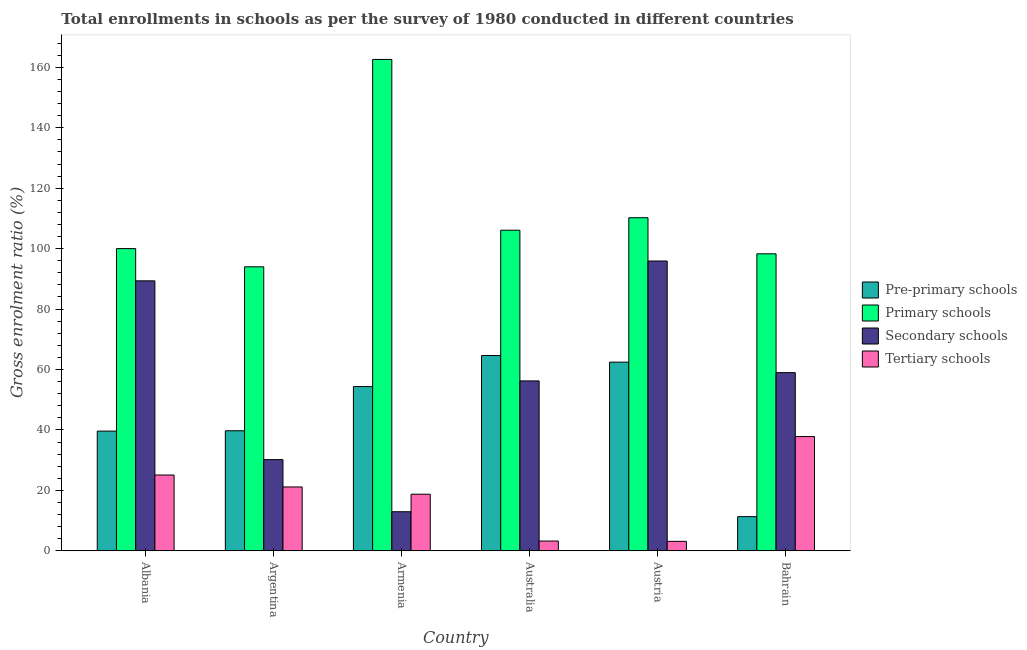How many different coloured bars are there?
Your response must be concise. 4. How many bars are there on the 2nd tick from the left?
Keep it short and to the point. 4. What is the label of the 2nd group of bars from the left?
Your answer should be compact. Argentina. What is the gross enrolment ratio in pre-primary schools in Armenia?
Make the answer very short. 54.34. Across all countries, what is the maximum gross enrolment ratio in primary schools?
Give a very brief answer. 162.62. Across all countries, what is the minimum gross enrolment ratio in secondary schools?
Make the answer very short. 12.93. In which country was the gross enrolment ratio in pre-primary schools maximum?
Ensure brevity in your answer.  Australia. What is the total gross enrolment ratio in pre-primary schools in the graph?
Give a very brief answer. 272.01. What is the difference between the gross enrolment ratio in tertiary schools in Albania and that in Argentina?
Ensure brevity in your answer.  3.95. What is the difference between the gross enrolment ratio in pre-primary schools in Australia and the gross enrolment ratio in tertiary schools in Argentina?
Make the answer very short. 43.5. What is the average gross enrolment ratio in tertiary schools per country?
Offer a very short reply. 18.18. What is the difference between the gross enrolment ratio in pre-primary schools and gross enrolment ratio in tertiary schools in Bahrain?
Ensure brevity in your answer.  -26.51. What is the ratio of the gross enrolment ratio in tertiary schools in Argentina to that in Armenia?
Offer a terse response. 1.13. Is the gross enrolment ratio in secondary schools in Albania less than that in Armenia?
Your answer should be compact. No. Is the difference between the gross enrolment ratio in secondary schools in Albania and Austria greater than the difference between the gross enrolment ratio in tertiary schools in Albania and Austria?
Offer a very short reply. No. What is the difference between the highest and the second highest gross enrolment ratio in pre-primary schools?
Ensure brevity in your answer.  2.19. What is the difference between the highest and the lowest gross enrolment ratio in secondary schools?
Provide a short and direct response. 82.98. In how many countries, is the gross enrolment ratio in primary schools greater than the average gross enrolment ratio in primary schools taken over all countries?
Your answer should be very brief. 1. Is it the case that in every country, the sum of the gross enrolment ratio in pre-primary schools and gross enrolment ratio in secondary schools is greater than the sum of gross enrolment ratio in primary schools and gross enrolment ratio in tertiary schools?
Make the answer very short. Yes. What does the 3rd bar from the left in Armenia represents?
Your answer should be compact. Secondary schools. What does the 4th bar from the right in Argentina represents?
Make the answer very short. Pre-primary schools. Is it the case that in every country, the sum of the gross enrolment ratio in pre-primary schools and gross enrolment ratio in primary schools is greater than the gross enrolment ratio in secondary schools?
Provide a succinct answer. Yes. How many bars are there?
Provide a succinct answer. 24. What is the difference between two consecutive major ticks on the Y-axis?
Make the answer very short. 20. Does the graph contain grids?
Keep it short and to the point. No. How many legend labels are there?
Offer a terse response. 4. What is the title of the graph?
Provide a succinct answer. Total enrollments in schools as per the survey of 1980 conducted in different countries. What is the Gross enrolment ratio (%) of Pre-primary schools in Albania?
Offer a very short reply. 39.61. What is the Gross enrolment ratio (%) in Primary schools in Albania?
Give a very brief answer. 100.01. What is the Gross enrolment ratio (%) in Secondary schools in Albania?
Your answer should be compact. 89.34. What is the Gross enrolment ratio (%) in Tertiary schools in Albania?
Your response must be concise. 25.07. What is the Gross enrolment ratio (%) in Pre-primary schools in Argentina?
Offer a very short reply. 39.72. What is the Gross enrolment ratio (%) in Primary schools in Argentina?
Your response must be concise. 93.98. What is the Gross enrolment ratio (%) in Secondary schools in Argentina?
Your response must be concise. 30.17. What is the Gross enrolment ratio (%) in Tertiary schools in Argentina?
Your answer should be very brief. 21.12. What is the Gross enrolment ratio (%) of Pre-primary schools in Armenia?
Provide a short and direct response. 54.34. What is the Gross enrolment ratio (%) in Primary schools in Armenia?
Provide a short and direct response. 162.62. What is the Gross enrolment ratio (%) of Secondary schools in Armenia?
Offer a very short reply. 12.93. What is the Gross enrolment ratio (%) in Tertiary schools in Armenia?
Your answer should be very brief. 18.72. What is the Gross enrolment ratio (%) of Pre-primary schools in Australia?
Provide a succinct answer. 64.62. What is the Gross enrolment ratio (%) in Primary schools in Australia?
Provide a succinct answer. 106.1. What is the Gross enrolment ratio (%) in Secondary schools in Australia?
Ensure brevity in your answer.  56.22. What is the Gross enrolment ratio (%) of Tertiary schools in Australia?
Offer a terse response. 3.22. What is the Gross enrolment ratio (%) in Pre-primary schools in Austria?
Your answer should be compact. 62.43. What is the Gross enrolment ratio (%) in Primary schools in Austria?
Offer a terse response. 110.23. What is the Gross enrolment ratio (%) in Secondary schools in Austria?
Keep it short and to the point. 95.9. What is the Gross enrolment ratio (%) of Tertiary schools in Austria?
Offer a very short reply. 3.12. What is the Gross enrolment ratio (%) in Pre-primary schools in Bahrain?
Your answer should be compact. 11.29. What is the Gross enrolment ratio (%) of Primary schools in Bahrain?
Give a very brief answer. 98.29. What is the Gross enrolment ratio (%) of Secondary schools in Bahrain?
Keep it short and to the point. 58.96. What is the Gross enrolment ratio (%) in Tertiary schools in Bahrain?
Provide a succinct answer. 37.8. Across all countries, what is the maximum Gross enrolment ratio (%) of Pre-primary schools?
Make the answer very short. 64.62. Across all countries, what is the maximum Gross enrolment ratio (%) in Primary schools?
Offer a very short reply. 162.62. Across all countries, what is the maximum Gross enrolment ratio (%) of Secondary schools?
Your answer should be compact. 95.9. Across all countries, what is the maximum Gross enrolment ratio (%) of Tertiary schools?
Your response must be concise. 37.8. Across all countries, what is the minimum Gross enrolment ratio (%) in Pre-primary schools?
Offer a terse response. 11.29. Across all countries, what is the minimum Gross enrolment ratio (%) in Primary schools?
Provide a short and direct response. 93.98. Across all countries, what is the minimum Gross enrolment ratio (%) in Secondary schools?
Your response must be concise. 12.93. Across all countries, what is the minimum Gross enrolment ratio (%) in Tertiary schools?
Offer a very short reply. 3.12. What is the total Gross enrolment ratio (%) of Pre-primary schools in the graph?
Ensure brevity in your answer.  272.01. What is the total Gross enrolment ratio (%) in Primary schools in the graph?
Ensure brevity in your answer.  671.23. What is the total Gross enrolment ratio (%) in Secondary schools in the graph?
Ensure brevity in your answer.  343.53. What is the total Gross enrolment ratio (%) of Tertiary schools in the graph?
Ensure brevity in your answer.  109.06. What is the difference between the Gross enrolment ratio (%) in Pre-primary schools in Albania and that in Argentina?
Offer a very short reply. -0.11. What is the difference between the Gross enrolment ratio (%) of Primary schools in Albania and that in Argentina?
Your answer should be very brief. 6.03. What is the difference between the Gross enrolment ratio (%) in Secondary schools in Albania and that in Argentina?
Provide a short and direct response. 59.17. What is the difference between the Gross enrolment ratio (%) in Tertiary schools in Albania and that in Argentina?
Give a very brief answer. 3.95. What is the difference between the Gross enrolment ratio (%) in Pre-primary schools in Albania and that in Armenia?
Provide a short and direct response. -14.74. What is the difference between the Gross enrolment ratio (%) of Primary schools in Albania and that in Armenia?
Your answer should be compact. -62.61. What is the difference between the Gross enrolment ratio (%) of Secondary schools in Albania and that in Armenia?
Provide a succinct answer. 76.42. What is the difference between the Gross enrolment ratio (%) of Tertiary schools in Albania and that in Armenia?
Give a very brief answer. 6.35. What is the difference between the Gross enrolment ratio (%) in Pre-primary schools in Albania and that in Australia?
Keep it short and to the point. -25.01. What is the difference between the Gross enrolment ratio (%) of Primary schools in Albania and that in Australia?
Offer a terse response. -6.09. What is the difference between the Gross enrolment ratio (%) of Secondary schools in Albania and that in Australia?
Give a very brief answer. 33.12. What is the difference between the Gross enrolment ratio (%) in Tertiary schools in Albania and that in Australia?
Provide a succinct answer. 21.85. What is the difference between the Gross enrolment ratio (%) of Pre-primary schools in Albania and that in Austria?
Your answer should be very brief. -22.82. What is the difference between the Gross enrolment ratio (%) of Primary schools in Albania and that in Austria?
Your answer should be compact. -10.22. What is the difference between the Gross enrolment ratio (%) in Secondary schools in Albania and that in Austria?
Make the answer very short. -6.56. What is the difference between the Gross enrolment ratio (%) in Tertiary schools in Albania and that in Austria?
Ensure brevity in your answer.  21.95. What is the difference between the Gross enrolment ratio (%) of Pre-primary schools in Albania and that in Bahrain?
Your answer should be compact. 28.31. What is the difference between the Gross enrolment ratio (%) in Primary schools in Albania and that in Bahrain?
Provide a succinct answer. 1.72. What is the difference between the Gross enrolment ratio (%) in Secondary schools in Albania and that in Bahrain?
Your response must be concise. 30.38. What is the difference between the Gross enrolment ratio (%) of Tertiary schools in Albania and that in Bahrain?
Your response must be concise. -12.73. What is the difference between the Gross enrolment ratio (%) in Pre-primary schools in Argentina and that in Armenia?
Keep it short and to the point. -14.63. What is the difference between the Gross enrolment ratio (%) of Primary schools in Argentina and that in Armenia?
Provide a short and direct response. -68.63. What is the difference between the Gross enrolment ratio (%) in Secondary schools in Argentina and that in Armenia?
Your response must be concise. 17.25. What is the difference between the Gross enrolment ratio (%) of Tertiary schools in Argentina and that in Armenia?
Provide a short and direct response. 2.4. What is the difference between the Gross enrolment ratio (%) of Pre-primary schools in Argentina and that in Australia?
Keep it short and to the point. -24.9. What is the difference between the Gross enrolment ratio (%) in Primary schools in Argentina and that in Australia?
Offer a very short reply. -12.11. What is the difference between the Gross enrolment ratio (%) of Secondary schools in Argentina and that in Australia?
Offer a terse response. -26.05. What is the difference between the Gross enrolment ratio (%) in Tertiary schools in Argentina and that in Australia?
Your response must be concise. 17.9. What is the difference between the Gross enrolment ratio (%) in Pre-primary schools in Argentina and that in Austria?
Make the answer very short. -22.71. What is the difference between the Gross enrolment ratio (%) in Primary schools in Argentina and that in Austria?
Provide a short and direct response. -16.25. What is the difference between the Gross enrolment ratio (%) of Secondary schools in Argentina and that in Austria?
Your answer should be compact. -65.73. What is the difference between the Gross enrolment ratio (%) of Tertiary schools in Argentina and that in Austria?
Offer a terse response. 18. What is the difference between the Gross enrolment ratio (%) of Pre-primary schools in Argentina and that in Bahrain?
Provide a short and direct response. 28.42. What is the difference between the Gross enrolment ratio (%) in Primary schools in Argentina and that in Bahrain?
Make the answer very short. -4.3. What is the difference between the Gross enrolment ratio (%) in Secondary schools in Argentina and that in Bahrain?
Keep it short and to the point. -28.79. What is the difference between the Gross enrolment ratio (%) of Tertiary schools in Argentina and that in Bahrain?
Your answer should be compact. -16.68. What is the difference between the Gross enrolment ratio (%) in Pre-primary schools in Armenia and that in Australia?
Offer a terse response. -10.27. What is the difference between the Gross enrolment ratio (%) in Primary schools in Armenia and that in Australia?
Keep it short and to the point. 56.52. What is the difference between the Gross enrolment ratio (%) of Secondary schools in Armenia and that in Australia?
Make the answer very short. -43.29. What is the difference between the Gross enrolment ratio (%) of Tertiary schools in Armenia and that in Australia?
Your answer should be very brief. 15.5. What is the difference between the Gross enrolment ratio (%) of Pre-primary schools in Armenia and that in Austria?
Your answer should be compact. -8.09. What is the difference between the Gross enrolment ratio (%) of Primary schools in Armenia and that in Austria?
Provide a succinct answer. 52.39. What is the difference between the Gross enrolment ratio (%) in Secondary schools in Armenia and that in Austria?
Offer a terse response. -82.98. What is the difference between the Gross enrolment ratio (%) of Tertiary schools in Armenia and that in Austria?
Ensure brevity in your answer.  15.6. What is the difference between the Gross enrolment ratio (%) in Pre-primary schools in Armenia and that in Bahrain?
Offer a terse response. 43.05. What is the difference between the Gross enrolment ratio (%) in Primary schools in Armenia and that in Bahrain?
Ensure brevity in your answer.  64.33. What is the difference between the Gross enrolment ratio (%) of Secondary schools in Armenia and that in Bahrain?
Give a very brief answer. -46.04. What is the difference between the Gross enrolment ratio (%) in Tertiary schools in Armenia and that in Bahrain?
Provide a succinct answer. -19.09. What is the difference between the Gross enrolment ratio (%) of Pre-primary schools in Australia and that in Austria?
Your response must be concise. 2.19. What is the difference between the Gross enrolment ratio (%) in Primary schools in Australia and that in Austria?
Ensure brevity in your answer.  -4.13. What is the difference between the Gross enrolment ratio (%) in Secondary schools in Australia and that in Austria?
Provide a short and direct response. -39.68. What is the difference between the Gross enrolment ratio (%) in Tertiary schools in Australia and that in Austria?
Offer a very short reply. 0.1. What is the difference between the Gross enrolment ratio (%) in Pre-primary schools in Australia and that in Bahrain?
Your answer should be very brief. 53.32. What is the difference between the Gross enrolment ratio (%) of Primary schools in Australia and that in Bahrain?
Your answer should be compact. 7.81. What is the difference between the Gross enrolment ratio (%) of Secondary schools in Australia and that in Bahrain?
Provide a succinct answer. -2.74. What is the difference between the Gross enrolment ratio (%) in Tertiary schools in Australia and that in Bahrain?
Offer a terse response. -34.58. What is the difference between the Gross enrolment ratio (%) of Pre-primary schools in Austria and that in Bahrain?
Keep it short and to the point. 51.14. What is the difference between the Gross enrolment ratio (%) of Primary schools in Austria and that in Bahrain?
Make the answer very short. 11.94. What is the difference between the Gross enrolment ratio (%) in Secondary schools in Austria and that in Bahrain?
Your answer should be very brief. 36.94. What is the difference between the Gross enrolment ratio (%) of Tertiary schools in Austria and that in Bahrain?
Your answer should be compact. -34.68. What is the difference between the Gross enrolment ratio (%) in Pre-primary schools in Albania and the Gross enrolment ratio (%) in Primary schools in Argentina?
Keep it short and to the point. -54.38. What is the difference between the Gross enrolment ratio (%) in Pre-primary schools in Albania and the Gross enrolment ratio (%) in Secondary schools in Argentina?
Your answer should be compact. 9.43. What is the difference between the Gross enrolment ratio (%) in Pre-primary schools in Albania and the Gross enrolment ratio (%) in Tertiary schools in Argentina?
Provide a short and direct response. 18.48. What is the difference between the Gross enrolment ratio (%) of Primary schools in Albania and the Gross enrolment ratio (%) of Secondary schools in Argentina?
Offer a very short reply. 69.84. What is the difference between the Gross enrolment ratio (%) of Primary schools in Albania and the Gross enrolment ratio (%) of Tertiary schools in Argentina?
Offer a very short reply. 78.89. What is the difference between the Gross enrolment ratio (%) in Secondary schools in Albania and the Gross enrolment ratio (%) in Tertiary schools in Argentina?
Give a very brief answer. 68.22. What is the difference between the Gross enrolment ratio (%) of Pre-primary schools in Albania and the Gross enrolment ratio (%) of Primary schools in Armenia?
Your response must be concise. -123.01. What is the difference between the Gross enrolment ratio (%) of Pre-primary schools in Albania and the Gross enrolment ratio (%) of Secondary schools in Armenia?
Offer a terse response. 26.68. What is the difference between the Gross enrolment ratio (%) of Pre-primary schools in Albania and the Gross enrolment ratio (%) of Tertiary schools in Armenia?
Your response must be concise. 20.89. What is the difference between the Gross enrolment ratio (%) in Primary schools in Albania and the Gross enrolment ratio (%) in Secondary schools in Armenia?
Provide a succinct answer. 87.09. What is the difference between the Gross enrolment ratio (%) of Primary schools in Albania and the Gross enrolment ratio (%) of Tertiary schools in Armenia?
Offer a terse response. 81.29. What is the difference between the Gross enrolment ratio (%) in Secondary schools in Albania and the Gross enrolment ratio (%) in Tertiary schools in Armenia?
Make the answer very short. 70.62. What is the difference between the Gross enrolment ratio (%) of Pre-primary schools in Albania and the Gross enrolment ratio (%) of Primary schools in Australia?
Offer a very short reply. -66.49. What is the difference between the Gross enrolment ratio (%) in Pre-primary schools in Albania and the Gross enrolment ratio (%) in Secondary schools in Australia?
Make the answer very short. -16.61. What is the difference between the Gross enrolment ratio (%) in Pre-primary schools in Albania and the Gross enrolment ratio (%) in Tertiary schools in Australia?
Make the answer very short. 36.38. What is the difference between the Gross enrolment ratio (%) in Primary schools in Albania and the Gross enrolment ratio (%) in Secondary schools in Australia?
Make the answer very short. 43.79. What is the difference between the Gross enrolment ratio (%) in Primary schools in Albania and the Gross enrolment ratio (%) in Tertiary schools in Australia?
Provide a succinct answer. 96.79. What is the difference between the Gross enrolment ratio (%) in Secondary schools in Albania and the Gross enrolment ratio (%) in Tertiary schools in Australia?
Ensure brevity in your answer.  86.12. What is the difference between the Gross enrolment ratio (%) of Pre-primary schools in Albania and the Gross enrolment ratio (%) of Primary schools in Austria?
Keep it short and to the point. -70.62. What is the difference between the Gross enrolment ratio (%) in Pre-primary schools in Albania and the Gross enrolment ratio (%) in Secondary schools in Austria?
Offer a very short reply. -56.3. What is the difference between the Gross enrolment ratio (%) in Pre-primary schools in Albania and the Gross enrolment ratio (%) in Tertiary schools in Austria?
Give a very brief answer. 36.49. What is the difference between the Gross enrolment ratio (%) of Primary schools in Albania and the Gross enrolment ratio (%) of Secondary schools in Austria?
Keep it short and to the point. 4.11. What is the difference between the Gross enrolment ratio (%) in Primary schools in Albania and the Gross enrolment ratio (%) in Tertiary schools in Austria?
Your response must be concise. 96.89. What is the difference between the Gross enrolment ratio (%) of Secondary schools in Albania and the Gross enrolment ratio (%) of Tertiary schools in Austria?
Your answer should be compact. 86.22. What is the difference between the Gross enrolment ratio (%) of Pre-primary schools in Albania and the Gross enrolment ratio (%) of Primary schools in Bahrain?
Your answer should be very brief. -58.68. What is the difference between the Gross enrolment ratio (%) of Pre-primary schools in Albania and the Gross enrolment ratio (%) of Secondary schools in Bahrain?
Provide a short and direct response. -19.36. What is the difference between the Gross enrolment ratio (%) of Pre-primary schools in Albania and the Gross enrolment ratio (%) of Tertiary schools in Bahrain?
Provide a short and direct response. 1.8. What is the difference between the Gross enrolment ratio (%) in Primary schools in Albania and the Gross enrolment ratio (%) in Secondary schools in Bahrain?
Give a very brief answer. 41.05. What is the difference between the Gross enrolment ratio (%) in Primary schools in Albania and the Gross enrolment ratio (%) in Tertiary schools in Bahrain?
Keep it short and to the point. 62.21. What is the difference between the Gross enrolment ratio (%) in Secondary schools in Albania and the Gross enrolment ratio (%) in Tertiary schools in Bahrain?
Offer a terse response. 51.54. What is the difference between the Gross enrolment ratio (%) in Pre-primary schools in Argentina and the Gross enrolment ratio (%) in Primary schools in Armenia?
Your answer should be compact. -122.9. What is the difference between the Gross enrolment ratio (%) of Pre-primary schools in Argentina and the Gross enrolment ratio (%) of Secondary schools in Armenia?
Your answer should be compact. 26.79. What is the difference between the Gross enrolment ratio (%) in Pre-primary schools in Argentina and the Gross enrolment ratio (%) in Tertiary schools in Armenia?
Your answer should be very brief. 21. What is the difference between the Gross enrolment ratio (%) of Primary schools in Argentina and the Gross enrolment ratio (%) of Secondary schools in Armenia?
Make the answer very short. 81.06. What is the difference between the Gross enrolment ratio (%) of Primary schools in Argentina and the Gross enrolment ratio (%) of Tertiary schools in Armenia?
Offer a terse response. 75.27. What is the difference between the Gross enrolment ratio (%) in Secondary schools in Argentina and the Gross enrolment ratio (%) in Tertiary schools in Armenia?
Your answer should be compact. 11.45. What is the difference between the Gross enrolment ratio (%) in Pre-primary schools in Argentina and the Gross enrolment ratio (%) in Primary schools in Australia?
Make the answer very short. -66.38. What is the difference between the Gross enrolment ratio (%) in Pre-primary schools in Argentina and the Gross enrolment ratio (%) in Secondary schools in Australia?
Offer a very short reply. -16.5. What is the difference between the Gross enrolment ratio (%) in Pre-primary schools in Argentina and the Gross enrolment ratio (%) in Tertiary schools in Australia?
Keep it short and to the point. 36.49. What is the difference between the Gross enrolment ratio (%) in Primary schools in Argentina and the Gross enrolment ratio (%) in Secondary schools in Australia?
Offer a very short reply. 37.76. What is the difference between the Gross enrolment ratio (%) in Primary schools in Argentina and the Gross enrolment ratio (%) in Tertiary schools in Australia?
Your answer should be very brief. 90.76. What is the difference between the Gross enrolment ratio (%) of Secondary schools in Argentina and the Gross enrolment ratio (%) of Tertiary schools in Australia?
Offer a terse response. 26.95. What is the difference between the Gross enrolment ratio (%) of Pre-primary schools in Argentina and the Gross enrolment ratio (%) of Primary schools in Austria?
Give a very brief answer. -70.51. What is the difference between the Gross enrolment ratio (%) in Pre-primary schools in Argentina and the Gross enrolment ratio (%) in Secondary schools in Austria?
Make the answer very short. -56.19. What is the difference between the Gross enrolment ratio (%) in Pre-primary schools in Argentina and the Gross enrolment ratio (%) in Tertiary schools in Austria?
Provide a succinct answer. 36.6. What is the difference between the Gross enrolment ratio (%) in Primary schools in Argentina and the Gross enrolment ratio (%) in Secondary schools in Austria?
Provide a short and direct response. -1.92. What is the difference between the Gross enrolment ratio (%) of Primary schools in Argentina and the Gross enrolment ratio (%) of Tertiary schools in Austria?
Ensure brevity in your answer.  90.86. What is the difference between the Gross enrolment ratio (%) in Secondary schools in Argentina and the Gross enrolment ratio (%) in Tertiary schools in Austria?
Provide a succinct answer. 27.05. What is the difference between the Gross enrolment ratio (%) in Pre-primary schools in Argentina and the Gross enrolment ratio (%) in Primary schools in Bahrain?
Provide a short and direct response. -58.57. What is the difference between the Gross enrolment ratio (%) of Pre-primary schools in Argentina and the Gross enrolment ratio (%) of Secondary schools in Bahrain?
Provide a succinct answer. -19.25. What is the difference between the Gross enrolment ratio (%) in Pre-primary schools in Argentina and the Gross enrolment ratio (%) in Tertiary schools in Bahrain?
Your answer should be very brief. 1.91. What is the difference between the Gross enrolment ratio (%) of Primary schools in Argentina and the Gross enrolment ratio (%) of Secondary schools in Bahrain?
Offer a terse response. 35.02. What is the difference between the Gross enrolment ratio (%) of Primary schools in Argentina and the Gross enrolment ratio (%) of Tertiary schools in Bahrain?
Your answer should be compact. 56.18. What is the difference between the Gross enrolment ratio (%) of Secondary schools in Argentina and the Gross enrolment ratio (%) of Tertiary schools in Bahrain?
Provide a short and direct response. -7.63. What is the difference between the Gross enrolment ratio (%) of Pre-primary schools in Armenia and the Gross enrolment ratio (%) of Primary schools in Australia?
Make the answer very short. -51.75. What is the difference between the Gross enrolment ratio (%) in Pre-primary schools in Armenia and the Gross enrolment ratio (%) in Secondary schools in Australia?
Provide a short and direct response. -1.88. What is the difference between the Gross enrolment ratio (%) of Pre-primary schools in Armenia and the Gross enrolment ratio (%) of Tertiary schools in Australia?
Give a very brief answer. 51.12. What is the difference between the Gross enrolment ratio (%) of Primary schools in Armenia and the Gross enrolment ratio (%) of Secondary schools in Australia?
Your response must be concise. 106.4. What is the difference between the Gross enrolment ratio (%) of Primary schools in Armenia and the Gross enrolment ratio (%) of Tertiary schools in Australia?
Give a very brief answer. 159.39. What is the difference between the Gross enrolment ratio (%) of Secondary schools in Armenia and the Gross enrolment ratio (%) of Tertiary schools in Australia?
Your answer should be very brief. 9.7. What is the difference between the Gross enrolment ratio (%) of Pre-primary schools in Armenia and the Gross enrolment ratio (%) of Primary schools in Austria?
Give a very brief answer. -55.89. What is the difference between the Gross enrolment ratio (%) in Pre-primary schools in Armenia and the Gross enrolment ratio (%) in Secondary schools in Austria?
Ensure brevity in your answer.  -41.56. What is the difference between the Gross enrolment ratio (%) in Pre-primary schools in Armenia and the Gross enrolment ratio (%) in Tertiary schools in Austria?
Offer a terse response. 51.22. What is the difference between the Gross enrolment ratio (%) in Primary schools in Armenia and the Gross enrolment ratio (%) in Secondary schools in Austria?
Make the answer very short. 66.71. What is the difference between the Gross enrolment ratio (%) of Primary schools in Armenia and the Gross enrolment ratio (%) of Tertiary schools in Austria?
Make the answer very short. 159.5. What is the difference between the Gross enrolment ratio (%) in Secondary schools in Armenia and the Gross enrolment ratio (%) in Tertiary schools in Austria?
Offer a very short reply. 9.8. What is the difference between the Gross enrolment ratio (%) in Pre-primary schools in Armenia and the Gross enrolment ratio (%) in Primary schools in Bahrain?
Offer a very short reply. -43.94. What is the difference between the Gross enrolment ratio (%) in Pre-primary schools in Armenia and the Gross enrolment ratio (%) in Secondary schools in Bahrain?
Your answer should be very brief. -4.62. What is the difference between the Gross enrolment ratio (%) in Pre-primary schools in Armenia and the Gross enrolment ratio (%) in Tertiary schools in Bahrain?
Your answer should be very brief. 16.54. What is the difference between the Gross enrolment ratio (%) of Primary schools in Armenia and the Gross enrolment ratio (%) of Secondary schools in Bahrain?
Your answer should be compact. 103.65. What is the difference between the Gross enrolment ratio (%) of Primary schools in Armenia and the Gross enrolment ratio (%) of Tertiary schools in Bahrain?
Give a very brief answer. 124.81. What is the difference between the Gross enrolment ratio (%) of Secondary schools in Armenia and the Gross enrolment ratio (%) of Tertiary schools in Bahrain?
Give a very brief answer. -24.88. What is the difference between the Gross enrolment ratio (%) of Pre-primary schools in Australia and the Gross enrolment ratio (%) of Primary schools in Austria?
Offer a very short reply. -45.61. What is the difference between the Gross enrolment ratio (%) in Pre-primary schools in Australia and the Gross enrolment ratio (%) in Secondary schools in Austria?
Offer a terse response. -31.29. What is the difference between the Gross enrolment ratio (%) in Pre-primary schools in Australia and the Gross enrolment ratio (%) in Tertiary schools in Austria?
Provide a succinct answer. 61.5. What is the difference between the Gross enrolment ratio (%) of Primary schools in Australia and the Gross enrolment ratio (%) of Secondary schools in Austria?
Provide a succinct answer. 10.19. What is the difference between the Gross enrolment ratio (%) in Primary schools in Australia and the Gross enrolment ratio (%) in Tertiary schools in Austria?
Offer a terse response. 102.98. What is the difference between the Gross enrolment ratio (%) in Secondary schools in Australia and the Gross enrolment ratio (%) in Tertiary schools in Austria?
Offer a terse response. 53.1. What is the difference between the Gross enrolment ratio (%) of Pre-primary schools in Australia and the Gross enrolment ratio (%) of Primary schools in Bahrain?
Ensure brevity in your answer.  -33.67. What is the difference between the Gross enrolment ratio (%) in Pre-primary schools in Australia and the Gross enrolment ratio (%) in Secondary schools in Bahrain?
Make the answer very short. 5.65. What is the difference between the Gross enrolment ratio (%) of Pre-primary schools in Australia and the Gross enrolment ratio (%) of Tertiary schools in Bahrain?
Make the answer very short. 26.81. What is the difference between the Gross enrolment ratio (%) in Primary schools in Australia and the Gross enrolment ratio (%) in Secondary schools in Bahrain?
Offer a very short reply. 47.14. What is the difference between the Gross enrolment ratio (%) in Primary schools in Australia and the Gross enrolment ratio (%) in Tertiary schools in Bahrain?
Keep it short and to the point. 68.29. What is the difference between the Gross enrolment ratio (%) of Secondary schools in Australia and the Gross enrolment ratio (%) of Tertiary schools in Bahrain?
Ensure brevity in your answer.  18.41. What is the difference between the Gross enrolment ratio (%) of Pre-primary schools in Austria and the Gross enrolment ratio (%) of Primary schools in Bahrain?
Offer a terse response. -35.86. What is the difference between the Gross enrolment ratio (%) of Pre-primary schools in Austria and the Gross enrolment ratio (%) of Secondary schools in Bahrain?
Your answer should be very brief. 3.47. What is the difference between the Gross enrolment ratio (%) in Pre-primary schools in Austria and the Gross enrolment ratio (%) in Tertiary schools in Bahrain?
Offer a terse response. 24.63. What is the difference between the Gross enrolment ratio (%) in Primary schools in Austria and the Gross enrolment ratio (%) in Secondary schools in Bahrain?
Your answer should be compact. 51.27. What is the difference between the Gross enrolment ratio (%) of Primary schools in Austria and the Gross enrolment ratio (%) of Tertiary schools in Bahrain?
Offer a terse response. 72.43. What is the difference between the Gross enrolment ratio (%) in Secondary schools in Austria and the Gross enrolment ratio (%) in Tertiary schools in Bahrain?
Make the answer very short. 58.1. What is the average Gross enrolment ratio (%) of Pre-primary schools per country?
Offer a very short reply. 45.33. What is the average Gross enrolment ratio (%) of Primary schools per country?
Your response must be concise. 111.87. What is the average Gross enrolment ratio (%) in Secondary schools per country?
Your answer should be compact. 57.25. What is the average Gross enrolment ratio (%) in Tertiary schools per country?
Offer a terse response. 18.18. What is the difference between the Gross enrolment ratio (%) of Pre-primary schools and Gross enrolment ratio (%) of Primary schools in Albania?
Give a very brief answer. -60.4. What is the difference between the Gross enrolment ratio (%) of Pre-primary schools and Gross enrolment ratio (%) of Secondary schools in Albania?
Provide a succinct answer. -49.74. What is the difference between the Gross enrolment ratio (%) of Pre-primary schools and Gross enrolment ratio (%) of Tertiary schools in Albania?
Offer a terse response. 14.54. What is the difference between the Gross enrolment ratio (%) in Primary schools and Gross enrolment ratio (%) in Secondary schools in Albania?
Your answer should be compact. 10.67. What is the difference between the Gross enrolment ratio (%) of Primary schools and Gross enrolment ratio (%) of Tertiary schools in Albania?
Offer a terse response. 74.94. What is the difference between the Gross enrolment ratio (%) in Secondary schools and Gross enrolment ratio (%) in Tertiary schools in Albania?
Offer a very short reply. 64.27. What is the difference between the Gross enrolment ratio (%) of Pre-primary schools and Gross enrolment ratio (%) of Primary schools in Argentina?
Your response must be concise. -54.27. What is the difference between the Gross enrolment ratio (%) of Pre-primary schools and Gross enrolment ratio (%) of Secondary schools in Argentina?
Make the answer very short. 9.54. What is the difference between the Gross enrolment ratio (%) of Pre-primary schools and Gross enrolment ratio (%) of Tertiary schools in Argentina?
Ensure brevity in your answer.  18.6. What is the difference between the Gross enrolment ratio (%) in Primary schools and Gross enrolment ratio (%) in Secondary schools in Argentina?
Make the answer very short. 63.81. What is the difference between the Gross enrolment ratio (%) of Primary schools and Gross enrolment ratio (%) of Tertiary schools in Argentina?
Provide a succinct answer. 72.86. What is the difference between the Gross enrolment ratio (%) of Secondary schools and Gross enrolment ratio (%) of Tertiary schools in Argentina?
Provide a succinct answer. 9.05. What is the difference between the Gross enrolment ratio (%) in Pre-primary schools and Gross enrolment ratio (%) in Primary schools in Armenia?
Offer a very short reply. -108.27. What is the difference between the Gross enrolment ratio (%) of Pre-primary schools and Gross enrolment ratio (%) of Secondary schools in Armenia?
Offer a terse response. 41.42. What is the difference between the Gross enrolment ratio (%) in Pre-primary schools and Gross enrolment ratio (%) in Tertiary schools in Armenia?
Keep it short and to the point. 35.63. What is the difference between the Gross enrolment ratio (%) of Primary schools and Gross enrolment ratio (%) of Secondary schools in Armenia?
Your answer should be compact. 149.69. What is the difference between the Gross enrolment ratio (%) of Primary schools and Gross enrolment ratio (%) of Tertiary schools in Armenia?
Give a very brief answer. 143.9. What is the difference between the Gross enrolment ratio (%) in Secondary schools and Gross enrolment ratio (%) in Tertiary schools in Armenia?
Give a very brief answer. -5.79. What is the difference between the Gross enrolment ratio (%) in Pre-primary schools and Gross enrolment ratio (%) in Primary schools in Australia?
Your response must be concise. -41.48. What is the difference between the Gross enrolment ratio (%) of Pre-primary schools and Gross enrolment ratio (%) of Secondary schools in Australia?
Give a very brief answer. 8.4. What is the difference between the Gross enrolment ratio (%) of Pre-primary schools and Gross enrolment ratio (%) of Tertiary schools in Australia?
Make the answer very short. 61.39. What is the difference between the Gross enrolment ratio (%) of Primary schools and Gross enrolment ratio (%) of Secondary schools in Australia?
Ensure brevity in your answer.  49.88. What is the difference between the Gross enrolment ratio (%) in Primary schools and Gross enrolment ratio (%) in Tertiary schools in Australia?
Your answer should be compact. 102.88. What is the difference between the Gross enrolment ratio (%) in Secondary schools and Gross enrolment ratio (%) in Tertiary schools in Australia?
Keep it short and to the point. 53. What is the difference between the Gross enrolment ratio (%) of Pre-primary schools and Gross enrolment ratio (%) of Primary schools in Austria?
Your response must be concise. -47.8. What is the difference between the Gross enrolment ratio (%) in Pre-primary schools and Gross enrolment ratio (%) in Secondary schools in Austria?
Make the answer very short. -33.47. What is the difference between the Gross enrolment ratio (%) of Pre-primary schools and Gross enrolment ratio (%) of Tertiary schools in Austria?
Provide a succinct answer. 59.31. What is the difference between the Gross enrolment ratio (%) in Primary schools and Gross enrolment ratio (%) in Secondary schools in Austria?
Keep it short and to the point. 14.33. What is the difference between the Gross enrolment ratio (%) in Primary schools and Gross enrolment ratio (%) in Tertiary schools in Austria?
Keep it short and to the point. 107.11. What is the difference between the Gross enrolment ratio (%) in Secondary schools and Gross enrolment ratio (%) in Tertiary schools in Austria?
Keep it short and to the point. 92.78. What is the difference between the Gross enrolment ratio (%) in Pre-primary schools and Gross enrolment ratio (%) in Primary schools in Bahrain?
Provide a short and direct response. -86.99. What is the difference between the Gross enrolment ratio (%) in Pre-primary schools and Gross enrolment ratio (%) in Secondary schools in Bahrain?
Your answer should be very brief. -47.67. What is the difference between the Gross enrolment ratio (%) of Pre-primary schools and Gross enrolment ratio (%) of Tertiary schools in Bahrain?
Offer a terse response. -26.51. What is the difference between the Gross enrolment ratio (%) in Primary schools and Gross enrolment ratio (%) in Secondary schools in Bahrain?
Your answer should be compact. 39.32. What is the difference between the Gross enrolment ratio (%) of Primary schools and Gross enrolment ratio (%) of Tertiary schools in Bahrain?
Your response must be concise. 60.48. What is the difference between the Gross enrolment ratio (%) in Secondary schools and Gross enrolment ratio (%) in Tertiary schools in Bahrain?
Your answer should be compact. 21.16. What is the ratio of the Gross enrolment ratio (%) in Pre-primary schools in Albania to that in Argentina?
Your answer should be compact. 1. What is the ratio of the Gross enrolment ratio (%) in Primary schools in Albania to that in Argentina?
Ensure brevity in your answer.  1.06. What is the ratio of the Gross enrolment ratio (%) of Secondary schools in Albania to that in Argentina?
Your response must be concise. 2.96. What is the ratio of the Gross enrolment ratio (%) in Tertiary schools in Albania to that in Argentina?
Ensure brevity in your answer.  1.19. What is the ratio of the Gross enrolment ratio (%) in Pre-primary schools in Albania to that in Armenia?
Offer a terse response. 0.73. What is the ratio of the Gross enrolment ratio (%) in Primary schools in Albania to that in Armenia?
Offer a very short reply. 0.61. What is the ratio of the Gross enrolment ratio (%) of Secondary schools in Albania to that in Armenia?
Your answer should be very brief. 6.91. What is the ratio of the Gross enrolment ratio (%) in Tertiary schools in Albania to that in Armenia?
Your answer should be very brief. 1.34. What is the ratio of the Gross enrolment ratio (%) of Pre-primary schools in Albania to that in Australia?
Your response must be concise. 0.61. What is the ratio of the Gross enrolment ratio (%) of Primary schools in Albania to that in Australia?
Your response must be concise. 0.94. What is the ratio of the Gross enrolment ratio (%) of Secondary schools in Albania to that in Australia?
Provide a succinct answer. 1.59. What is the ratio of the Gross enrolment ratio (%) in Tertiary schools in Albania to that in Australia?
Provide a succinct answer. 7.78. What is the ratio of the Gross enrolment ratio (%) of Pre-primary schools in Albania to that in Austria?
Provide a succinct answer. 0.63. What is the ratio of the Gross enrolment ratio (%) of Primary schools in Albania to that in Austria?
Provide a short and direct response. 0.91. What is the ratio of the Gross enrolment ratio (%) in Secondary schools in Albania to that in Austria?
Provide a short and direct response. 0.93. What is the ratio of the Gross enrolment ratio (%) of Tertiary schools in Albania to that in Austria?
Make the answer very short. 8.03. What is the ratio of the Gross enrolment ratio (%) of Pre-primary schools in Albania to that in Bahrain?
Give a very brief answer. 3.51. What is the ratio of the Gross enrolment ratio (%) in Primary schools in Albania to that in Bahrain?
Your answer should be compact. 1.02. What is the ratio of the Gross enrolment ratio (%) in Secondary schools in Albania to that in Bahrain?
Ensure brevity in your answer.  1.52. What is the ratio of the Gross enrolment ratio (%) in Tertiary schools in Albania to that in Bahrain?
Give a very brief answer. 0.66. What is the ratio of the Gross enrolment ratio (%) in Pre-primary schools in Argentina to that in Armenia?
Keep it short and to the point. 0.73. What is the ratio of the Gross enrolment ratio (%) in Primary schools in Argentina to that in Armenia?
Provide a succinct answer. 0.58. What is the ratio of the Gross enrolment ratio (%) in Secondary schools in Argentina to that in Armenia?
Give a very brief answer. 2.33. What is the ratio of the Gross enrolment ratio (%) of Tertiary schools in Argentina to that in Armenia?
Give a very brief answer. 1.13. What is the ratio of the Gross enrolment ratio (%) of Pre-primary schools in Argentina to that in Australia?
Give a very brief answer. 0.61. What is the ratio of the Gross enrolment ratio (%) of Primary schools in Argentina to that in Australia?
Your response must be concise. 0.89. What is the ratio of the Gross enrolment ratio (%) of Secondary schools in Argentina to that in Australia?
Your response must be concise. 0.54. What is the ratio of the Gross enrolment ratio (%) of Tertiary schools in Argentina to that in Australia?
Your answer should be very brief. 6.55. What is the ratio of the Gross enrolment ratio (%) of Pre-primary schools in Argentina to that in Austria?
Keep it short and to the point. 0.64. What is the ratio of the Gross enrolment ratio (%) of Primary schools in Argentina to that in Austria?
Your answer should be very brief. 0.85. What is the ratio of the Gross enrolment ratio (%) in Secondary schools in Argentina to that in Austria?
Your response must be concise. 0.31. What is the ratio of the Gross enrolment ratio (%) in Tertiary schools in Argentina to that in Austria?
Your response must be concise. 6.77. What is the ratio of the Gross enrolment ratio (%) of Pre-primary schools in Argentina to that in Bahrain?
Your answer should be very brief. 3.52. What is the ratio of the Gross enrolment ratio (%) in Primary schools in Argentina to that in Bahrain?
Your response must be concise. 0.96. What is the ratio of the Gross enrolment ratio (%) of Secondary schools in Argentina to that in Bahrain?
Your answer should be very brief. 0.51. What is the ratio of the Gross enrolment ratio (%) in Tertiary schools in Argentina to that in Bahrain?
Your answer should be compact. 0.56. What is the ratio of the Gross enrolment ratio (%) in Pre-primary schools in Armenia to that in Australia?
Your answer should be compact. 0.84. What is the ratio of the Gross enrolment ratio (%) in Primary schools in Armenia to that in Australia?
Your response must be concise. 1.53. What is the ratio of the Gross enrolment ratio (%) of Secondary schools in Armenia to that in Australia?
Your response must be concise. 0.23. What is the ratio of the Gross enrolment ratio (%) in Tertiary schools in Armenia to that in Australia?
Give a very brief answer. 5.81. What is the ratio of the Gross enrolment ratio (%) in Pre-primary schools in Armenia to that in Austria?
Keep it short and to the point. 0.87. What is the ratio of the Gross enrolment ratio (%) in Primary schools in Armenia to that in Austria?
Your response must be concise. 1.48. What is the ratio of the Gross enrolment ratio (%) of Secondary schools in Armenia to that in Austria?
Your answer should be compact. 0.13. What is the ratio of the Gross enrolment ratio (%) of Tertiary schools in Armenia to that in Austria?
Your answer should be compact. 6. What is the ratio of the Gross enrolment ratio (%) of Pre-primary schools in Armenia to that in Bahrain?
Make the answer very short. 4.81. What is the ratio of the Gross enrolment ratio (%) in Primary schools in Armenia to that in Bahrain?
Your response must be concise. 1.65. What is the ratio of the Gross enrolment ratio (%) in Secondary schools in Armenia to that in Bahrain?
Ensure brevity in your answer.  0.22. What is the ratio of the Gross enrolment ratio (%) of Tertiary schools in Armenia to that in Bahrain?
Ensure brevity in your answer.  0.5. What is the ratio of the Gross enrolment ratio (%) of Pre-primary schools in Australia to that in Austria?
Offer a very short reply. 1.03. What is the ratio of the Gross enrolment ratio (%) in Primary schools in Australia to that in Austria?
Provide a short and direct response. 0.96. What is the ratio of the Gross enrolment ratio (%) in Secondary schools in Australia to that in Austria?
Offer a very short reply. 0.59. What is the ratio of the Gross enrolment ratio (%) of Tertiary schools in Australia to that in Austria?
Ensure brevity in your answer.  1.03. What is the ratio of the Gross enrolment ratio (%) in Pre-primary schools in Australia to that in Bahrain?
Give a very brief answer. 5.72. What is the ratio of the Gross enrolment ratio (%) of Primary schools in Australia to that in Bahrain?
Offer a terse response. 1.08. What is the ratio of the Gross enrolment ratio (%) in Secondary schools in Australia to that in Bahrain?
Offer a terse response. 0.95. What is the ratio of the Gross enrolment ratio (%) in Tertiary schools in Australia to that in Bahrain?
Provide a succinct answer. 0.09. What is the ratio of the Gross enrolment ratio (%) in Pre-primary schools in Austria to that in Bahrain?
Provide a short and direct response. 5.53. What is the ratio of the Gross enrolment ratio (%) in Primary schools in Austria to that in Bahrain?
Offer a very short reply. 1.12. What is the ratio of the Gross enrolment ratio (%) in Secondary schools in Austria to that in Bahrain?
Your answer should be very brief. 1.63. What is the ratio of the Gross enrolment ratio (%) in Tertiary schools in Austria to that in Bahrain?
Offer a very short reply. 0.08. What is the difference between the highest and the second highest Gross enrolment ratio (%) in Pre-primary schools?
Your answer should be very brief. 2.19. What is the difference between the highest and the second highest Gross enrolment ratio (%) of Primary schools?
Your answer should be compact. 52.39. What is the difference between the highest and the second highest Gross enrolment ratio (%) of Secondary schools?
Offer a terse response. 6.56. What is the difference between the highest and the second highest Gross enrolment ratio (%) of Tertiary schools?
Your response must be concise. 12.73. What is the difference between the highest and the lowest Gross enrolment ratio (%) in Pre-primary schools?
Give a very brief answer. 53.32. What is the difference between the highest and the lowest Gross enrolment ratio (%) of Primary schools?
Ensure brevity in your answer.  68.63. What is the difference between the highest and the lowest Gross enrolment ratio (%) of Secondary schools?
Provide a short and direct response. 82.98. What is the difference between the highest and the lowest Gross enrolment ratio (%) of Tertiary schools?
Your answer should be very brief. 34.68. 